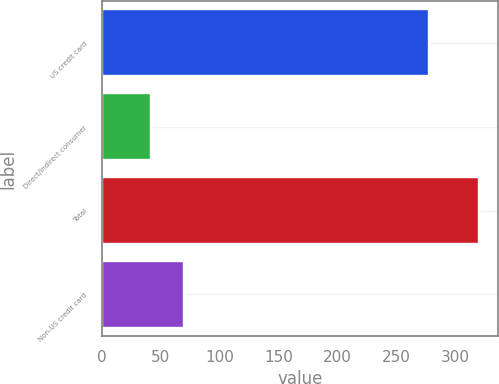<chart> <loc_0><loc_0><loc_500><loc_500><bar_chart><fcel>US credit card<fcel>Direct/Indirect consumer<fcel>Total<fcel>Non-US credit card<nl><fcel>278<fcel>42<fcel>320<fcel>69.8<nl></chart> 